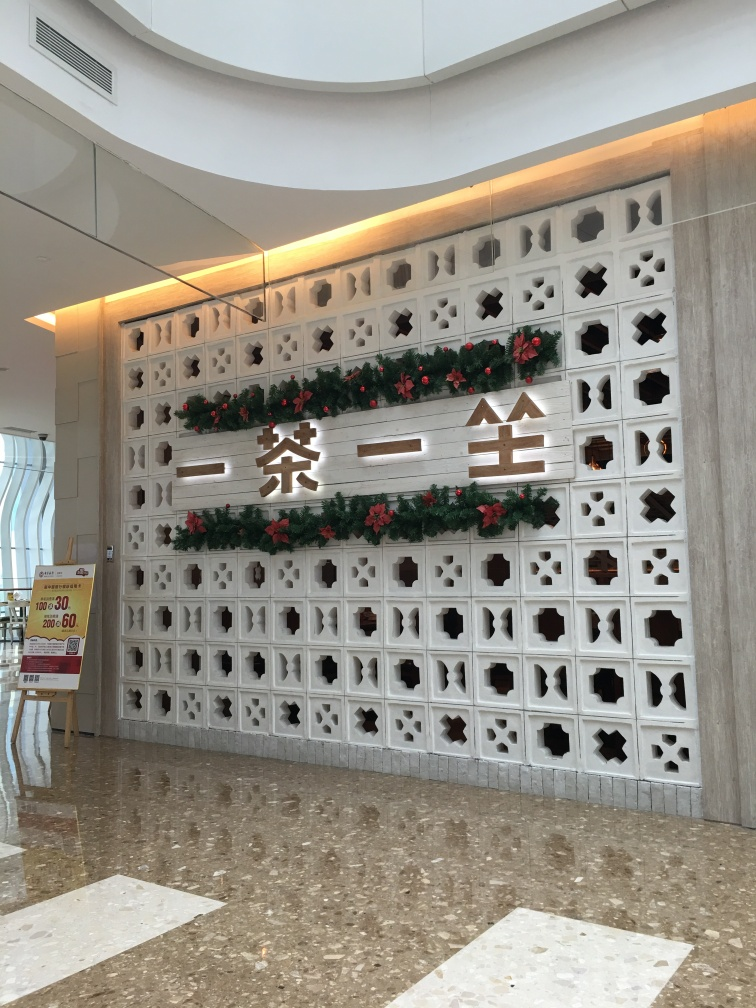Can you describe how the space is likely used based on its design? The design of the space, with its large, unobstructed floor and aesthetic yet functional wall, suggests it is used for social or public gatherings. The presence of a promotional sign also hints that this area might serve commercial functions, possibly in a mall or a hospitality setting like a hotel lobby. The festive decorations imply the space’s versatility in hosting seasonal or themed events. 